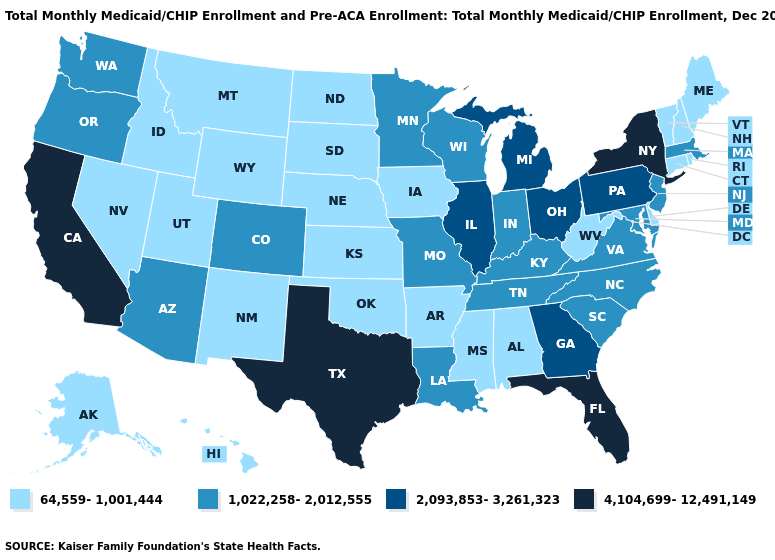Does New Hampshire have the lowest value in the Northeast?
Give a very brief answer. Yes. Does the map have missing data?
Answer briefly. No. Name the states that have a value in the range 2,093,853-3,261,323?
Give a very brief answer. Georgia, Illinois, Michigan, Ohio, Pennsylvania. Does Michigan have the highest value in the MidWest?
Answer briefly. Yes. What is the value of Alabama?
Answer briefly. 64,559-1,001,444. Which states have the highest value in the USA?
Short answer required. California, Florida, New York, Texas. Does the map have missing data?
Short answer required. No. Does Oregon have a lower value than Maryland?
Keep it brief. No. Among the states that border Minnesota , does Wisconsin have the highest value?
Keep it brief. Yes. Among the states that border New York , which have the lowest value?
Be succinct. Connecticut, Vermont. What is the value of Oregon?
Quick response, please. 1,022,258-2,012,555. What is the value of Washington?
Answer briefly. 1,022,258-2,012,555. Which states hav the highest value in the West?
Short answer required. California. How many symbols are there in the legend?
Write a very short answer. 4. Does North Dakota have the highest value in the MidWest?
Give a very brief answer. No. 